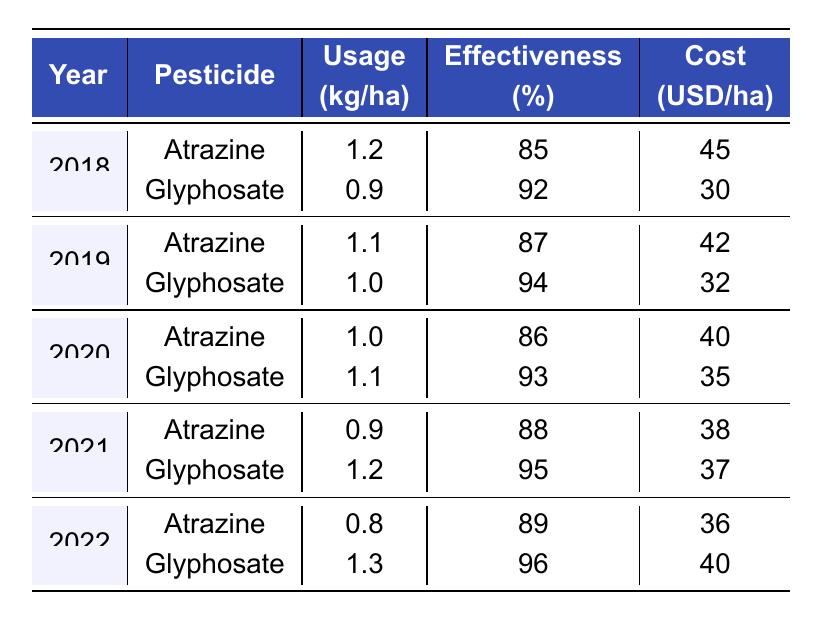What is the usage of Atrazine in 2021? Atrazine's usage in 2021 is found by checking the row for Atrazine under the year 2021. In that row, the usage is stated as 0.9 kg per hectare.
Answer: 0.9 kg/ha What percentage effectiveness does Glyphosate have in 2022? To find Glyphosate's effectiveness in 2022, look at the row for Glyphosate under 2022. The effectiveness is listed as 96%.
Answer: 96% Which pesticide had the lowest cost per hectare in 2019? By comparing costs in the 2019 rows, Atrazine has a cost of 42 USD per hectare, while Glyphosate is 32 USD per hectare. Glyphosate's cost is lower, making it the cheapest.
Answer: Glyphosate What is the average effectiveness of Atrazine across all the years? Calculate Atrazine's effectiveness by summing its effectiveness values: (85 + 87 + 86 + 88 + 89) = 435. There are 5 values, so the average is 435 / 5 = 87.
Answer: 87% In which year did Glyphosate have the highest usage? Check the usage values for Glyphosate: 0.9 (2018), 1.0 (2019), 1.1 (2020), 1.2 (2021), 1.3 (2022). The highest value is 1.3 in 2022.
Answer: 2022 What was the cost difference between Atrazine and Glyphosate in 2020? Determine the costs for both pesticides in 2020, where Atrazine is 40 USD and Glyphosate is 35 USD. The difference is 40 - 35 = 5 USD.
Answer: 5 USD Is the effectiveness of Glyphosate consistently above 90% from 2018 to 2022? Check the effectiveness values: 92% (2018), 94% (2019), 93% (2020), 95% (2021), 96% (2022). All values are above 90%, confirming consistency.
Answer: Yes What is the overall trend in Atrazine usage from 2018 to 2022? Review Atrazine's usage: 1.2 (2018), 1.1 (2019), 1.0 (2020), 0.9 (2021), 0.8 (2022). The values are decreasing each year, indicating a downward trend.
Answer: Decreasing How does Glyphosate's usage in 2021 compare to its usage in 2020? Glyphosate usage in 2021 is 1.2 kg/ha and in 2020 it is 1.1 kg/ha. Comparing these, 1.2 is greater than 1.1, so usage increased.
Answer: Increased Which pesticide was used more in 2019, and by how much? In 2019, Atrazine was used at 1.1 kg/ha, while Glyphosate was at 1.0 kg/ha. The difference is 1.1 - 1.0 = 0.1 kg/ha, indicating Atrazine was used more.
Answer: Atrazine, by 0.1 kg/ha 